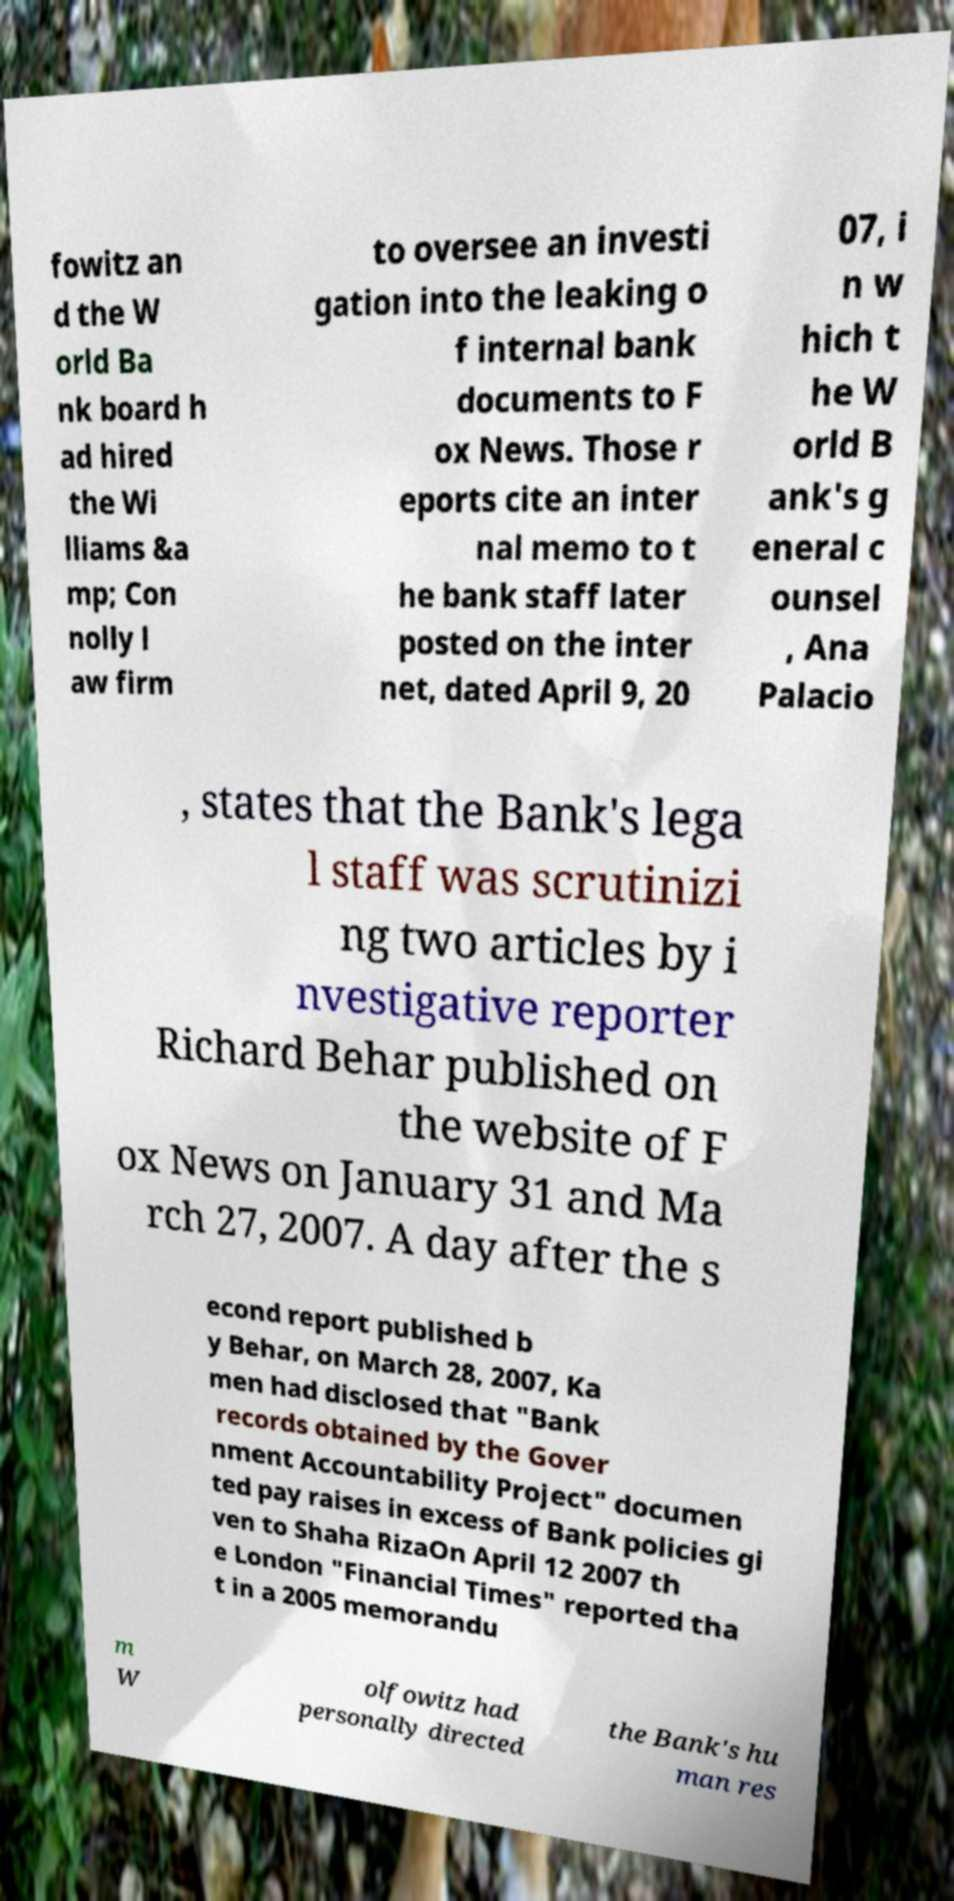For documentation purposes, I need the text within this image transcribed. Could you provide that? fowitz an d the W orld Ba nk board h ad hired the Wi lliams &a mp; Con nolly l aw firm to oversee an investi gation into the leaking o f internal bank documents to F ox News. Those r eports cite an inter nal memo to t he bank staff later posted on the inter net, dated April 9, 20 07, i n w hich t he W orld B ank's g eneral c ounsel , Ana Palacio , states that the Bank's lega l staff was scrutinizi ng two articles by i nvestigative reporter Richard Behar published on the website of F ox News on January 31 and Ma rch 27, 2007. A day after the s econd report published b y Behar, on March 28, 2007, Ka men had disclosed that "Bank records obtained by the Gover nment Accountability Project" documen ted pay raises in excess of Bank policies gi ven to Shaha RizaOn April 12 2007 th e London "Financial Times" reported tha t in a 2005 memorandu m W olfowitz had personally directed the Bank's hu man res 